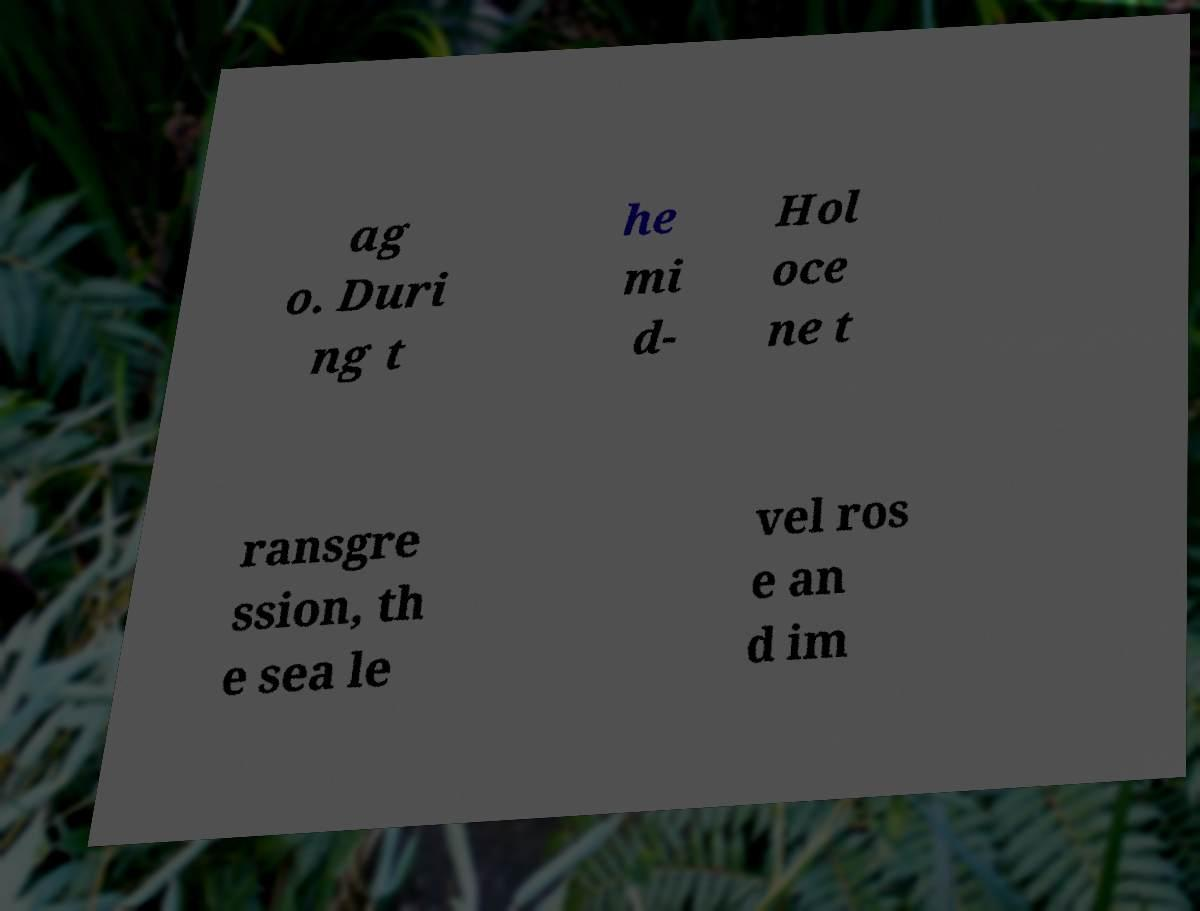What messages or text are displayed in this image? I need them in a readable, typed format. ag o. Duri ng t he mi d- Hol oce ne t ransgre ssion, th e sea le vel ros e an d im 